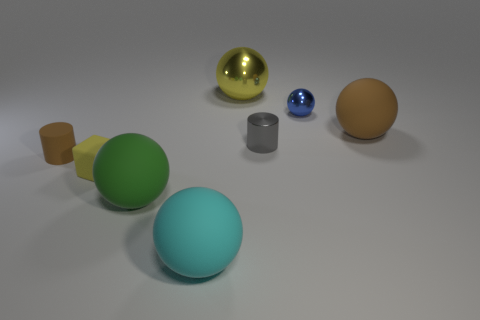Is there a gray metal cylinder?
Offer a very short reply. Yes. Are there any other gray cylinders made of the same material as the gray cylinder?
Give a very brief answer. No. Are there more small yellow cubes on the left side of the tiny gray metallic object than objects on the right side of the cyan rubber ball?
Offer a very short reply. No. Is the brown rubber cylinder the same size as the cube?
Give a very brief answer. Yes. What is the color of the tiny cylinder behind the brown rubber object left of the blue sphere?
Provide a succinct answer. Gray. What is the color of the small metallic ball?
Your answer should be compact. Blue. Is there a object of the same color as the rubber cylinder?
Offer a very short reply. Yes. Is the color of the tiny cylinder that is to the left of the rubber cube the same as the big shiny sphere?
Your answer should be compact. No. How many objects are either yellow things in front of the small shiny cylinder or big blue metal cylinders?
Provide a succinct answer. 1. Are there any brown matte spheres on the left side of the yellow metal ball?
Make the answer very short. No. 